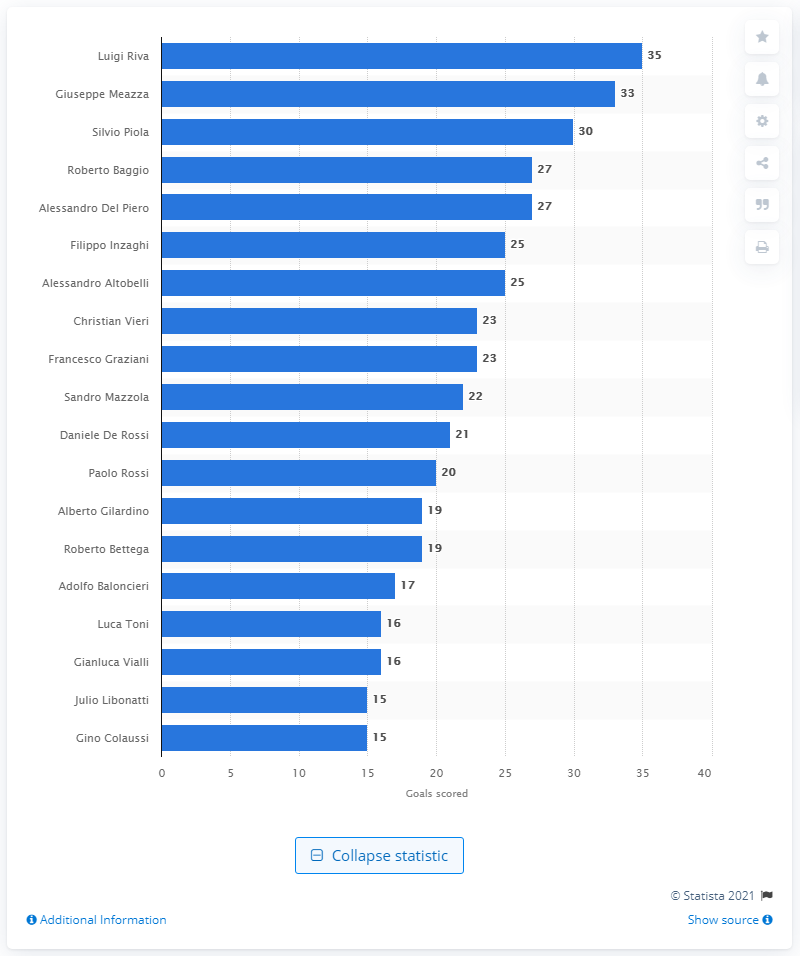Identify some key points in this picture. Giuseppe Meazza scored 33 goals. Luigi Riva is the all-time leading goal scorer for the Italian national football team. 